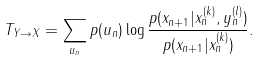Convert formula to latex. <formula><loc_0><loc_0><loc_500><loc_500>T _ { Y \rightarrow X } = \sum _ { u _ { n } } p ( u _ { n } ) \log { \frac { p ( x _ { n + 1 } | x ^ { ( k ) } _ { n } , y ^ { ( l ) } _ { n } ) } { p ( x _ { n + 1 } | x ^ { ( k ) } _ { n } ) } } .</formula> 